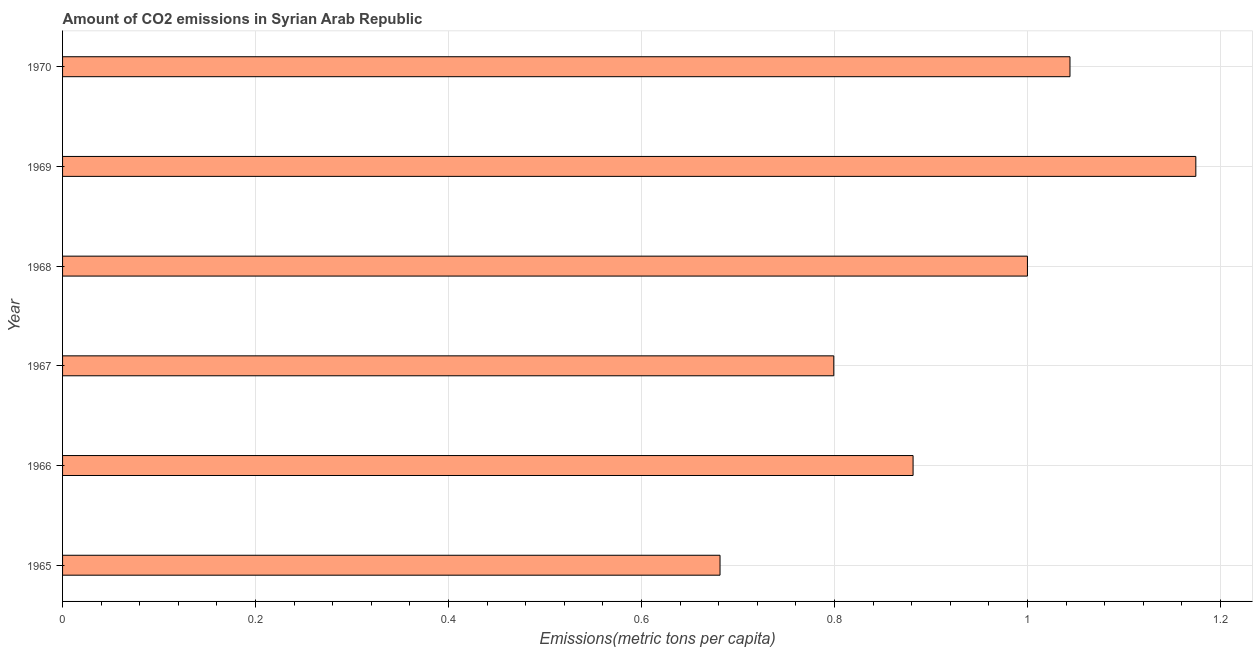Does the graph contain any zero values?
Ensure brevity in your answer.  No. Does the graph contain grids?
Your answer should be compact. Yes. What is the title of the graph?
Make the answer very short. Amount of CO2 emissions in Syrian Arab Republic. What is the label or title of the X-axis?
Your response must be concise. Emissions(metric tons per capita). What is the amount of co2 emissions in 1969?
Make the answer very short. 1.17. Across all years, what is the maximum amount of co2 emissions?
Your response must be concise. 1.17. Across all years, what is the minimum amount of co2 emissions?
Offer a terse response. 0.68. In which year was the amount of co2 emissions maximum?
Offer a very short reply. 1969. In which year was the amount of co2 emissions minimum?
Offer a terse response. 1965. What is the sum of the amount of co2 emissions?
Make the answer very short. 5.58. What is the difference between the amount of co2 emissions in 1966 and 1967?
Keep it short and to the point. 0.08. What is the median amount of co2 emissions?
Provide a short and direct response. 0.94. In how many years, is the amount of co2 emissions greater than 0.24 metric tons per capita?
Your answer should be very brief. 6. Do a majority of the years between 1967 and 1970 (inclusive) have amount of co2 emissions greater than 1.12 metric tons per capita?
Provide a succinct answer. No. What is the ratio of the amount of co2 emissions in 1967 to that in 1969?
Ensure brevity in your answer.  0.68. Is the amount of co2 emissions in 1968 less than that in 1969?
Make the answer very short. Yes. What is the difference between the highest and the second highest amount of co2 emissions?
Your answer should be compact. 0.13. What is the difference between the highest and the lowest amount of co2 emissions?
Provide a succinct answer. 0.49. In how many years, is the amount of co2 emissions greater than the average amount of co2 emissions taken over all years?
Offer a terse response. 3. Are all the bars in the graph horizontal?
Ensure brevity in your answer.  Yes. What is the difference between two consecutive major ticks on the X-axis?
Offer a very short reply. 0.2. Are the values on the major ticks of X-axis written in scientific E-notation?
Keep it short and to the point. No. What is the Emissions(metric tons per capita) in 1965?
Make the answer very short. 0.68. What is the Emissions(metric tons per capita) in 1966?
Make the answer very short. 0.88. What is the Emissions(metric tons per capita) in 1967?
Keep it short and to the point. 0.8. What is the Emissions(metric tons per capita) in 1968?
Ensure brevity in your answer.  1. What is the Emissions(metric tons per capita) in 1969?
Offer a terse response. 1.17. What is the Emissions(metric tons per capita) of 1970?
Make the answer very short. 1.04. What is the difference between the Emissions(metric tons per capita) in 1965 and 1966?
Your answer should be very brief. -0.2. What is the difference between the Emissions(metric tons per capita) in 1965 and 1967?
Give a very brief answer. -0.12. What is the difference between the Emissions(metric tons per capita) in 1965 and 1968?
Provide a succinct answer. -0.32. What is the difference between the Emissions(metric tons per capita) in 1965 and 1969?
Your answer should be very brief. -0.49. What is the difference between the Emissions(metric tons per capita) in 1965 and 1970?
Keep it short and to the point. -0.36. What is the difference between the Emissions(metric tons per capita) in 1966 and 1967?
Make the answer very short. 0.08. What is the difference between the Emissions(metric tons per capita) in 1966 and 1968?
Make the answer very short. -0.12. What is the difference between the Emissions(metric tons per capita) in 1966 and 1969?
Your response must be concise. -0.29. What is the difference between the Emissions(metric tons per capita) in 1966 and 1970?
Give a very brief answer. -0.16. What is the difference between the Emissions(metric tons per capita) in 1967 and 1968?
Your answer should be compact. -0.2. What is the difference between the Emissions(metric tons per capita) in 1967 and 1969?
Offer a terse response. -0.38. What is the difference between the Emissions(metric tons per capita) in 1967 and 1970?
Give a very brief answer. -0.24. What is the difference between the Emissions(metric tons per capita) in 1968 and 1969?
Keep it short and to the point. -0.17. What is the difference between the Emissions(metric tons per capita) in 1968 and 1970?
Offer a terse response. -0.04. What is the difference between the Emissions(metric tons per capita) in 1969 and 1970?
Offer a very short reply. 0.13. What is the ratio of the Emissions(metric tons per capita) in 1965 to that in 1966?
Offer a terse response. 0.77. What is the ratio of the Emissions(metric tons per capita) in 1965 to that in 1967?
Provide a succinct answer. 0.85. What is the ratio of the Emissions(metric tons per capita) in 1965 to that in 1968?
Your answer should be compact. 0.68. What is the ratio of the Emissions(metric tons per capita) in 1965 to that in 1969?
Offer a terse response. 0.58. What is the ratio of the Emissions(metric tons per capita) in 1965 to that in 1970?
Offer a very short reply. 0.65. What is the ratio of the Emissions(metric tons per capita) in 1966 to that in 1967?
Your answer should be very brief. 1.1. What is the ratio of the Emissions(metric tons per capita) in 1966 to that in 1968?
Keep it short and to the point. 0.88. What is the ratio of the Emissions(metric tons per capita) in 1966 to that in 1969?
Make the answer very short. 0.75. What is the ratio of the Emissions(metric tons per capita) in 1966 to that in 1970?
Offer a terse response. 0.84. What is the ratio of the Emissions(metric tons per capita) in 1967 to that in 1968?
Give a very brief answer. 0.8. What is the ratio of the Emissions(metric tons per capita) in 1967 to that in 1969?
Your answer should be very brief. 0.68. What is the ratio of the Emissions(metric tons per capita) in 1967 to that in 1970?
Provide a short and direct response. 0.77. What is the ratio of the Emissions(metric tons per capita) in 1968 to that in 1969?
Ensure brevity in your answer.  0.85. What is the ratio of the Emissions(metric tons per capita) in 1968 to that in 1970?
Your answer should be compact. 0.96. What is the ratio of the Emissions(metric tons per capita) in 1969 to that in 1970?
Offer a terse response. 1.12. 